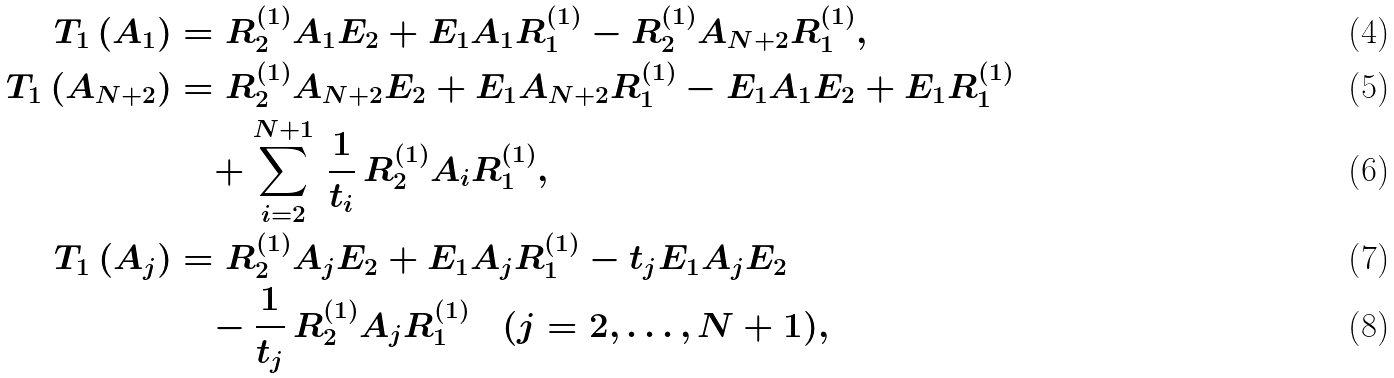Convert formula to latex. <formula><loc_0><loc_0><loc_500><loc_500>T _ { 1 } \, ( A _ { 1 } ) & = R _ { 2 } ^ { ( 1 ) } A _ { 1 } E _ { 2 } + E _ { 1 } A _ { 1 } R _ { 1 } ^ { ( 1 ) } - R _ { 2 } ^ { ( 1 ) } A _ { N + 2 } R _ { 1 } ^ { ( 1 ) } , \\ T _ { 1 } \, ( A _ { N + 2 } ) & = R _ { 2 } ^ { ( 1 ) } A _ { N + 2 } E _ { 2 } + E _ { 1 } A _ { N + 2 } R _ { 1 } ^ { ( 1 ) } - E _ { 1 } A _ { 1 } E _ { 2 } + E _ { 1 } R _ { 1 } ^ { ( 1 ) } \\ & \quad + \sum _ { i = 2 } ^ { N + 1 } \, \frac { 1 } { t _ { i } } \, R _ { 2 } ^ { ( 1 ) } A _ { i } R _ { 1 } ^ { ( 1 ) } , \\ T _ { 1 } \, ( A _ { j } ) & = R _ { 2 } ^ { ( 1 ) } A _ { j } E _ { 2 } + E _ { 1 } A _ { j } R _ { 1 } ^ { ( 1 ) } - t _ { j } E _ { 1 } A _ { j } E _ { 2 } \\ & \quad - \frac { 1 } { t _ { j } } \, R _ { 2 } ^ { ( 1 ) } A _ { j } R _ { 1 } ^ { ( 1 ) } \quad ( j = 2 , \dots , N + 1 ) ,</formula> 